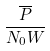<formula> <loc_0><loc_0><loc_500><loc_500>\frac { \overline { P } } { N _ { 0 } W }</formula> 